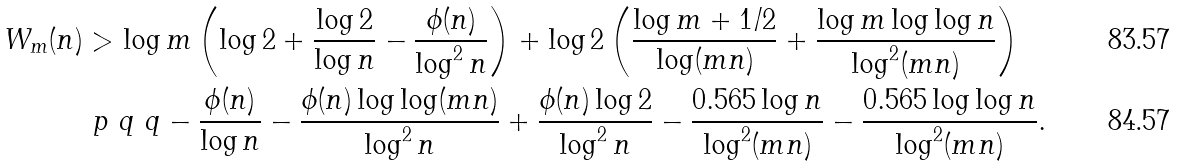Convert formula to latex. <formula><loc_0><loc_0><loc_500><loc_500>W _ { m } ( n ) & > \log m \left ( \log 2 + \frac { \log 2 } { \log n } - \frac { \phi ( n ) } { \log ^ { 2 } n } \right ) + \log 2 \left ( \frac { \log m + 1 / 2 } { \log ( m n ) } + \frac { \log m \log \log n } { \log ^ { 2 } ( m n ) } \right ) \\ & \ p { \ q \ q } - \frac { \phi ( n ) } { \log n } - \frac { \phi ( n ) \log \log ( m n ) } { \log ^ { 2 } n } + \frac { \phi ( n ) \log 2 } { \log ^ { 2 } n } - \frac { 0 . 5 6 5 \log n } { \log ^ { 2 } ( m n ) } - \frac { 0 . 5 6 5 \log \log n } { \log ^ { 2 } ( m n ) } .</formula> 